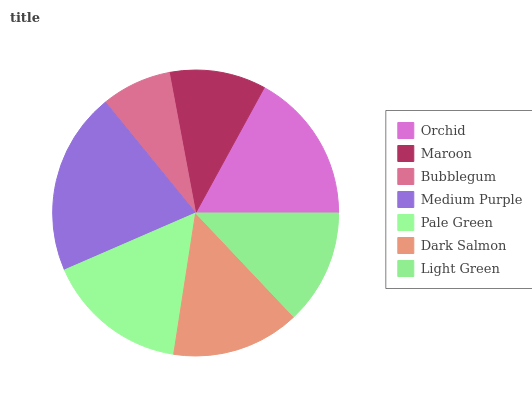Is Bubblegum the minimum?
Answer yes or no. Yes. Is Medium Purple the maximum?
Answer yes or no. Yes. Is Maroon the minimum?
Answer yes or no. No. Is Maroon the maximum?
Answer yes or no. No. Is Orchid greater than Maroon?
Answer yes or no. Yes. Is Maroon less than Orchid?
Answer yes or no. Yes. Is Maroon greater than Orchid?
Answer yes or no. No. Is Orchid less than Maroon?
Answer yes or no. No. Is Dark Salmon the high median?
Answer yes or no. Yes. Is Dark Salmon the low median?
Answer yes or no. Yes. Is Orchid the high median?
Answer yes or no. No. Is Orchid the low median?
Answer yes or no. No. 